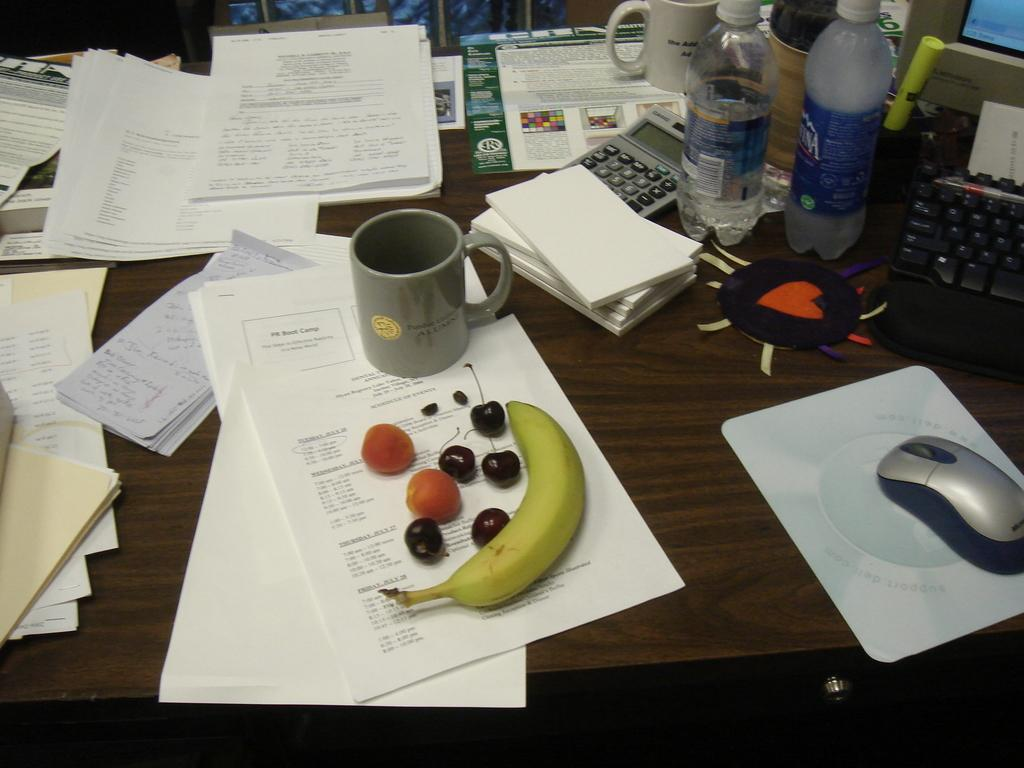What type of objects can be seen in the image? There are papers, a cup, a banana, fruits, a book, a calculator, a water bottle, a mouse, a mouse pad, a keyboard, and a monitor in the image. What is the color of the table on which the objects are placed? The table is brown. Can you identify any food items in the image? Yes, there is a banana and other fruits in the image. What type of electronic device is present in the image? There is a monitor in the image. How does the rainstorm affect the objects in the image? There is no rainstorm present in the image, so its effects cannot be observed. What type of basketball is visible in the image? There is no basketball present in the image. 